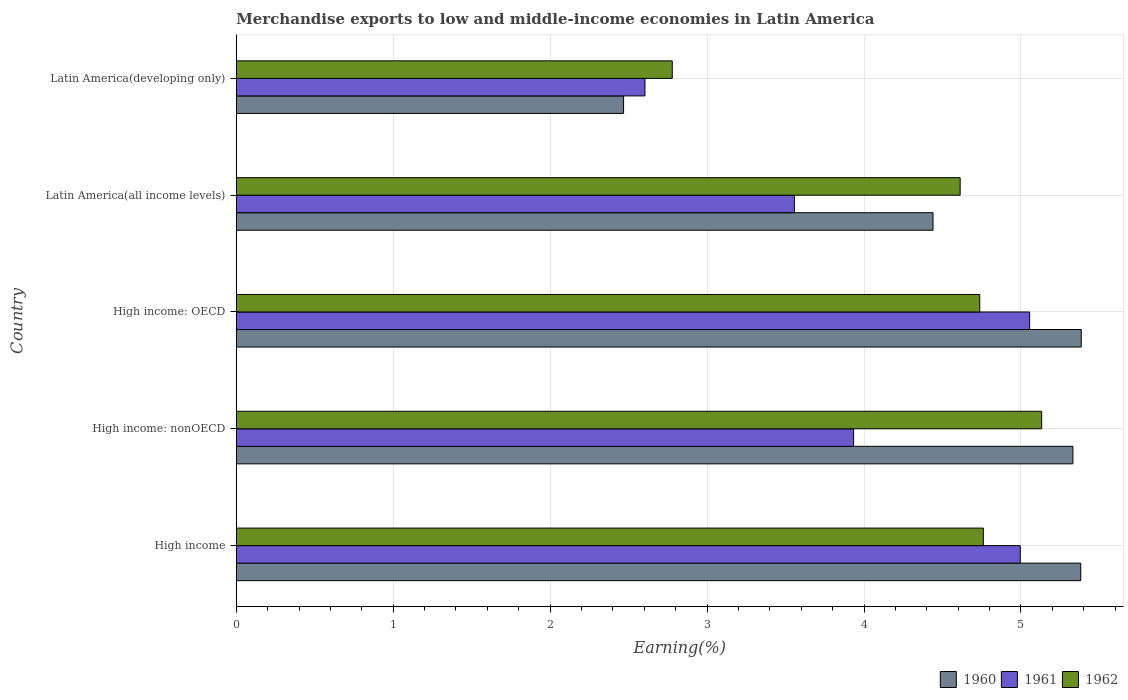How many different coloured bars are there?
Your answer should be compact. 3. Are the number of bars per tick equal to the number of legend labels?
Keep it short and to the point. Yes. Are the number of bars on each tick of the Y-axis equal?
Provide a short and direct response. Yes. What is the label of the 5th group of bars from the top?
Your response must be concise. High income. What is the percentage of amount earned from merchandise exports in 1962 in High income?
Your response must be concise. 4.76. Across all countries, what is the maximum percentage of amount earned from merchandise exports in 1962?
Keep it short and to the point. 5.13. Across all countries, what is the minimum percentage of amount earned from merchandise exports in 1962?
Provide a succinct answer. 2.78. In which country was the percentage of amount earned from merchandise exports in 1960 maximum?
Your answer should be very brief. High income: OECD. In which country was the percentage of amount earned from merchandise exports in 1961 minimum?
Provide a short and direct response. Latin America(developing only). What is the total percentage of amount earned from merchandise exports in 1960 in the graph?
Your response must be concise. 23. What is the difference between the percentage of amount earned from merchandise exports in 1962 in High income and that in Latin America(all income levels)?
Offer a terse response. 0.15. What is the difference between the percentage of amount earned from merchandise exports in 1961 in Latin America(all income levels) and the percentage of amount earned from merchandise exports in 1960 in Latin America(developing only)?
Make the answer very short. 1.09. What is the average percentage of amount earned from merchandise exports in 1962 per country?
Ensure brevity in your answer.  4.4. What is the difference between the percentage of amount earned from merchandise exports in 1962 and percentage of amount earned from merchandise exports in 1960 in Latin America(all income levels)?
Your answer should be very brief. 0.17. In how many countries, is the percentage of amount earned from merchandise exports in 1960 greater than 2.4 %?
Your answer should be compact. 5. What is the ratio of the percentage of amount earned from merchandise exports in 1961 in High income to that in Latin America(developing only)?
Keep it short and to the point. 1.92. Is the difference between the percentage of amount earned from merchandise exports in 1962 in High income and High income: OECD greater than the difference between the percentage of amount earned from merchandise exports in 1960 in High income and High income: OECD?
Provide a succinct answer. Yes. What is the difference between the highest and the second highest percentage of amount earned from merchandise exports in 1960?
Keep it short and to the point. 0. What is the difference between the highest and the lowest percentage of amount earned from merchandise exports in 1961?
Offer a terse response. 2.45. In how many countries, is the percentage of amount earned from merchandise exports in 1961 greater than the average percentage of amount earned from merchandise exports in 1961 taken over all countries?
Your answer should be very brief. 2. Is the sum of the percentage of amount earned from merchandise exports in 1961 in Latin America(all income levels) and Latin America(developing only) greater than the maximum percentage of amount earned from merchandise exports in 1962 across all countries?
Provide a succinct answer. Yes. What does the 2nd bar from the top in High income: OECD represents?
Make the answer very short. 1961. Are all the bars in the graph horizontal?
Your answer should be very brief. Yes. Are the values on the major ticks of X-axis written in scientific E-notation?
Give a very brief answer. No. Does the graph contain any zero values?
Offer a terse response. No. Does the graph contain grids?
Your response must be concise. Yes. Where does the legend appear in the graph?
Provide a succinct answer. Bottom right. How are the legend labels stacked?
Your response must be concise. Horizontal. What is the title of the graph?
Your answer should be very brief. Merchandise exports to low and middle-income economies in Latin America. Does "2007" appear as one of the legend labels in the graph?
Offer a very short reply. No. What is the label or title of the X-axis?
Keep it short and to the point. Earning(%). What is the Earning(%) of 1960 in High income?
Provide a short and direct response. 5.38. What is the Earning(%) in 1961 in High income?
Your answer should be compact. 5. What is the Earning(%) in 1962 in High income?
Provide a short and direct response. 4.76. What is the Earning(%) in 1960 in High income: nonOECD?
Provide a short and direct response. 5.33. What is the Earning(%) in 1961 in High income: nonOECD?
Ensure brevity in your answer.  3.93. What is the Earning(%) in 1962 in High income: nonOECD?
Your response must be concise. 5.13. What is the Earning(%) in 1960 in High income: OECD?
Provide a short and direct response. 5.38. What is the Earning(%) of 1961 in High income: OECD?
Provide a succinct answer. 5.06. What is the Earning(%) in 1962 in High income: OECD?
Your answer should be very brief. 4.74. What is the Earning(%) in 1960 in Latin America(all income levels)?
Ensure brevity in your answer.  4.44. What is the Earning(%) in 1961 in Latin America(all income levels)?
Provide a short and direct response. 3.56. What is the Earning(%) of 1962 in Latin America(all income levels)?
Your answer should be very brief. 4.61. What is the Earning(%) in 1960 in Latin America(developing only)?
Provide a succinct answer. 2.47. What is the Earning(%) in 1961 in Latin America(developing only)?
Give a very brief answer. 2.6. What is the Earning(%) in 1962 in Latin America(developing only)?
Ensure brevity in your answer.  2.78. Across all countries, what is the maximum Earning(%) of 1960?
Your answer should be compact. 5.38. Across all countries, what is the maximum Earning(%) in 1961?
Provide a succinct answer. 5.06. Across all countries, what is the maximum Earning(%) of 1962?
Offer a very short reply. 5.13. Across all countries, what is the minimum Earning(%) in 1960?
Give a very brief answer. 2.47. Across all countries, what is the minimum Earning(%) of 1961?
Offer a terse response. 2.6. Across all countries, what is the minimum Earning(%) of 1962?
Provide a short and direct response. 2.78. What is the total Earning(%) in 1960 in the graph?
Offer a very short reply. 23. What is the total Earning(%) in 1961 in the graph?
Offer a very short reply. 20.15. What is the total Earning(%) of 1962 in the graph?
Ensure brevity in your answer.  22.02. What is the difference between the Earning(%) in 1960 in High income and that in High income: nonOECD?
Your response must be concise. 0.05. What is the difference between the Earning(%) of 1961 in High income and that in High income: nonOECD?
Keep it short and to the point. 1.06. What is the difference between the Earning(%) in 1962 in High income and that in High income: nonOECD?
Your answer should be compact. -0.37. What is the difference between the Earning(%) of 1960 in High income and that in High income: OECD?
Offer a very short reply. -0. What is the difference between the Earning(%) in 1961 in High income and that in High income: OECD?
Your answer should be very brief. -0.06. What is the difference between the Earning(%) of 1962 in High income and that in High income: OECD?
Your answer should be compact. 0.02. What is the difference between the Earning(%) of 1960 in High income and that in Latin America(all income levels)?
Make the answer very short. 0.94. What is the difference between the Earning(%) in 1961 in High income and that in Latin America(all income levels)?
Make the answer very short. 1.44. What is the difference between the Earning(%) in 1962 in High income and that in Latin America(all income levels)?
Ensure brevity in your answer.  0.15. What is the difference between the Earning(%) of 1960 in High income and that in Latin America(developing only)?
Offer a terse response. 2.91. What is the difference between the Earning(%) of 1961 in High income and that in Latin America(developing only)?
Keep it short and to the point. 2.39. What is the difference between the Earning(%) of 1962 in High income and that in Latin America(developing only)?
Your answer should be very brief. 1.98. What is the difference between the Earning(%) in 1960 in High income: nonOECD and that in High income: OECD?
Your answer should be very brief. -0.05. What is the difference between the Earning(%) of 1961 in High income: nonOECD and that in High income: OECD?
Provide a succinct answer. -1.12. What is the difference between the Earning(%) in 1962 in High income: nonOECD and that in High income: OECD?
Give a very brief answer. 0.39. What is the difference between the Earning(%) of 1960 in High income: nonOECD and that in Latin America(all income levels)?
Give a very brief answer. 0.89. What is the difference between the Earning(%) in 1961 in High income: nonOECD and that in Latin America(all income levels)?
Give a very brief answer. 0.38. What is the difference between the Earning(%) in 1962 in High income: nonOECD and that in Latin America(all income levels)?
Ensure brevity in your answer.  0.52. What is the difference between the Earning(%) in 1960 in High income: nonOECD and that in Latin America(developing only)?
Ensure brevity in your answer.  2.86. What is the difference between the Earning(%) of 1961 in High income: nonOECD and that in Latin America(developing only)?
Your answer should be compact. 1.33. What is the difference between the Earning(%) of 1962 in High income: nonOECD and that in Latin America(developing only)?
Ensure brevity in your answer.  2.35. What is the difference between the Earning(%) in 1960 in High income: OECD and that in Latin America(all income levels)?
Your answer should be very brief. 0.94. What is the difference between the Earning(%) in 1961 in High income: OECD and that in Latin America(all income levels)?
Provide a succinct answer. 1.5. What is the difference between the Earning(%) in 1962 in High income: OECD and that in Latin America(all income levels)?
Give a very brief answer. 0.12. What is the difference between the Earning(%) in 1960 in High income: OECD and that in Latin America(developing only)?
Make the answer very short. 2.92. What is the difference between the Earning(%) in 1961 in High income: OECD and that in Latin America(developing only)?
Offer a very short reply. 2.45. What is the difference between the Earning(%) in 1962 in High income: OECD and that in Latin America(developing only)?
Your response must be concise. 1.96. What is the difference between the Earning(%) in 1960 in Latin America(all income levels) and that in Latin America(developing only)?
Provide a short and direct response. 1.97. What is the difference between the Earning(%) in 1961 in Latin America(all income levels) and that in Latin America(developing only)?
Offer a terse response. 0.95. What is the difference between the Earning(%) in 1962 in Latin America(all income levels) and that in Latin America(developing only)?
Provide a short and direct response. 1.83. What is the difference between the Earning(%) in 1960 in High income and the Earning(%) in 1961 in High income: nonOECD?
Provide a short and direct response. 1.45. What is the difference between the Earning(%) of 1960 in High income and the Earning(%) of 1962 in High income: nonOECD?
Offer a very short reply. 0.25. What is the difference between the Earning(%) in 1961 in High income and the Earning(%) in 1962 in High income: nonOECD?
Offer a terse response. -0.14. What is the difference between the Earning(%) in 1960 in High income and the Earning(%) in 1961 in High income: OECD?
Offer a terse response. 0.33. What is the difference between the Earning(%) of 1960 in High income and the Earning(%) of 1962 in High income: OECD?
Your answer should be compact. 0.64. What is the difference between the Earning(%) in 1961 in High income and the Earning(%) in 1962 in High income: OECD?
Your answer should be very brief. 0.26. What is the difference between the Earning(%) in 1960 in High income and the Earning(%) in 1961 in Latin America(all income levels)?
Your answer should be very brief. 1.82. What is the difference between the Earning(%) of 1960 in High income and the Earning(%) of 1962 in Latin America(all income levels)?
Provide a short and direct response. 0.77. What is the difference between the Earning(%) in 1961 in High income and the Earning(%) in 1962 in Latin America(all income levels)?
Keep it short and to the point. 0.38. What is the difference between the Earning(%) of 1960 in High income and the Earning(%) of 1961 in Latin America(developing only)?
Ensure brevity in your answer.  2.78. What is the difference between the Earning(%) of 1960 in High income and the Earning(%) of 1962 in Latin America(developing only)?
Give a very brief answer. 2.6. What is the difference between the Earning(%) in 1961 in High income and the Earning(%) in 1962 in Latin America(developing only)?
Ensure brevity in your answer.  2.22. What is the difference between the Earning(%) in 1960 in High income: nonOECD and the Earning(%) in 1961 in High income: OECD?
Provide a succinct answer. 0.28. What is the difference between the Earning(%) in 1960 in High income: nonOECD and the Earning(%) in 1962 in High income: OECD?
Your answer should be compact. 0.59. What is the difference between the Earning(%) in 1961 in High income: nonOECD and the Earning(%) in 1962 in High income: OECD?
Your answer should be compact. -0.8. What is the difference between the Earning(%) of 1960 in High income: nonOECD and the Earning(%) of 1961 in Latin America(all income levels)?
Offer a terse response. 1.77. What is the difference between the Earning(%) in 1960 in High income: nonOECD and the Earning(%) in 1962 in Latin America(all income levels)?
Your response must be concise. 0.72. What is the difference between the Earning(%) of 1961 in High income: nonOECD and the Earning(%) of 1962 in Latin America(all income levels)?
Your response must be concise. -0.68. What is the difference between the Earning(%) in 1960 in High income: nonOECD and the Earning(%) in 1961 in Latin America(developing only)?
Make the answer very short. 2.73. What is the difference between the Earning(%) of 1960 in High income: nonOECD and the Earning(%) of 1962 in Latin America(developing only)?
Offer a very short reply. 2.55. What is the difference between the Earning(%) of 1961 in High income: nonOECD and the Earning(%) of 1962 in Latin America(developing only)?
Provide a short and direct response. 1.16. What is the difference between the Earning(%) of 1960 in High income: OECD and the Earning(%) of 1961 in Latin America(all income levels)?
Keep it short and to the point. 1.83. What is the difference between the Earning(%) of 1960 in High income: OECD and the Earning(%) of 1962 in Latin America(all income levels)?
Make the answer very short. 0.77. What is the difference between the Earning(%) of 1961 in High income: OECD and the Earning(%) of 1962 in Latin America(all income levels)?
Your answer should be very brief. 0.44. What is the difference between the Earning(%) of 1960 in High income: OECD and the Earning(%) of 1961 in Latin America(developing only)?
Ensure brevity in your answer.  2.78. What is the difference between the Earning(%) in 1960 in High income: OECD and the Earning(%) in 1962 in Latin America(developing only)?
Keep it short and to the point. 2.61. What is the difference between the Earning(%) of 1961 in High income: OECD and the Earning(%) of 1962 in Latin America(developing only)?
Your answer should be compact. 2.28. What is the difference between the Earning(%) of 1960 in Latin America(all income levels) and the Earning(%) of 1961 in Latin America(developing only)?
Keep it short and to the point. 1.84. What is the difference between the Earning(%) in 1960 in Latin America(all income levels) and the Earning(%) in 1962 in Latin America(developing only)?
Make the answer very short. 1.66. What is the difference between the Earning(%) in 1961 in Latin America(all income levels) and the Earning(%) in 1962 in Latin America(developing only)?
Make the answer very short. 0.78. What is the average Earning(%) in 1960 per country?
Your answer should be compact. 4.6. What is the average Earning(%) of 1961 per country?
Make the answer very short. 4.03. What is the average Earning(%) in 1962 per country?
Ensure brevity in your answer.  4.4. What is the difference between the Earning(%) in 1960 and Earning(%) in 1961 in High income?
Your answer should be compact. 0.39. What is the difference between the Earning(%) of 1960 and Earning(%) of 1962 in High income?
Make the answer very short. 0.62. What is the difference between the Earning(%) of 1961 and Earning(%) of 1962 in High income?
Provide a short and direct response. 0.24. What is the difference between the Earning(%) of 1960 and Earning(%) of 1961 in High income: nonOECD?
Keep it short and to the point. 1.4. What is the difference between the Earning(%) of 1960 and Earning(%) of 1962 in High income: nonOECD?
Your answer should be very brief. 0.2. What is the difference between the Earning(%) of 1961 and Earning(%) of 1962 in High income: nonOECD?
Your answer should be compact. -1.2. What is the difference between the Earning(%) in 1960 and Earning(%) in 1961 in High income: OECD?
Provide a succinct answer. 0.33. What is the difference between the Earning(%) of 1960 and Earning(%) of 1962 in High income: OECD?
Give a very brief answer. 0.65. What is the difference between the Earning(%) of 1961 and Earning(%) of 1962 in High income: OECD?
Offer a terse response. 0.32. What is the difference between the Earning(%) of 1960 and Earning(%) of 1961 in Latin America(all income levels)?
Ensure brevity in your answer.  0.88. What is the difference between the Earning(%) in 1960 and Earning(%) in 1962 in Latin America(all income levels)?
Your answer should be very brief. -0.17. What is the difference between the Earning(%) of 1961 and Earning(%) of 1962 in Latin America(all income levels)?
Offer a terse response. -1.06. What is the difference between the Earning(%) of 1960 and Earning(%) of 1961 in Latin America(developing only)?
Offer a terse response. -0.14. What is the difference between the Earning(%) in 1960 and Earning(%) in 1962 in Latin America(developing only)?
Offer a very short reply. -0.31. What is the difference between the Earning(%) of 1961 and Earning(%) of 1962 in Latin America(developing only)?
Make the answer very short. -0.17. What is the ratio of the Earning(%) in 1960 in High income to that in High income: nonOECD?
Your answer should be very brief. 1.01. What is the ratio of the Earning(%) of 1961 in High income to that in High income: nonOECD?
Your response must be concise. 1.27. What is the ratio of the Earning(%) of 1962 in High income to that in High income: nonOECD?
Offer a terse response. 0.93. What is the ratio of the Earning(%) of 1960 in High income to that in High income: OECD?
Provide a succinct answer. 1. What is the ratio of the Earning(%) in 1960 in High income to that in Latin America(all income levels)?
Make the answer very short. 1.21. What is the ratio of the Earning(%) in 1961 in High income to that in Latin America(all income levels)?
Make the answer very short. 1.4. What is the ratio of the Earning(%) in 1962 in High income to that in Latin America(all income levels)?
Ensure brevity in your answer.  1.03. What is the ratio of the Earning(%) of 1960 in High income to that in Latin America(developing only)?
Your answer should be compact. 2.18. What is the ratio of the Earning(%) in 1961 in High income to that in Latin America(developing only)?
Your answer should be compact. 1.92. What is the ratio of the Earning(%) in 1962 in High income to that in Latin America(developing only)?
Your response must be concise. 1.71. What is the ratio of the Earning(%) of 1960 in High income: nonOECD to that in High income: OECD?
Your response must be concise. 0.99. What is the ratio of the Earning(%) of 1961 in High income: nonOECD to that in High income: OECD?
Provide a short and direct response. 0.78. What is the ratio of the Earning(%) of 1962 in High income: nonOECD to that in High income: OECD?
Make the answer very short. 1.08. What is the ratio of the Earning(%) in 1960 in High income: nonOECD to that in Latin America(all income levels)?
Make the answer very short. 1.2. What is the ratio of the Earning(%) of 1961 in High income: nonOECD to that in Latin America(all income levels)?
Your response must be concise. 1.11. What is the ratio of the Earning(%) in 1962 in High income: nonOECD to that in Latin America(all income levels)?
Your answer should be very brief. 1.11. What is the ratio of the Earning(%) in 1960 in High income: nonOECD to that in Latin America(developing only)?
Give a very brief answer. 2.16. What is the ratio of the Earning(%) in 1961 in High income: nonOECD to that in Latin America(developing only)?
Offer a terse response. 1.51. What is the ratio of the Earning(%) in 1962 in High income: nonOECD to that in Latin America(developing only)?
Make the answer very short. 1.85. What is the ratio of the Earning(%) in 1960 in High income: OECD to that in Latin America(all income levels)?
Your response must be concise. 1.21. What is the ratio of the Earning(%) of 1961 in High income: OECD to that in Latin America(all income levels)?
Your answer should be very brief. 1.42. What is the ratio of the Earning(%) of 1960 in High income: OECD to that in Latin America(developing only)?
Offer a terse response. 2.18. What is the ratio of the Earning(%) of 1961 in High income: OECD to that in Latin America(developing only)?
Ensure brevity in your answer.  1.94. What is the ratio of the Earning(%) of 1962 in High income: OECD to that in Latin America(developing only)?
Your response must be concise. 1.71. What is the ratio of the Earning(%) of 1960 in Latin America(all income levels) to that in Latin America(developing only)?
Ensure brevity in your answer.  1.8. What is the ratio of the Earning(%) in 1961 in Latin America(all income levels) to that in Latin America(developing only)?
Keep it short and to the point. 1.37. What is the ratio of the Earning(%) in 1962 in Latin America(all income levels) to that in Latin America(developing only)?
Make the answer very short. 1.66. What is the difference between the highest and the second highest Earning(%) of 1960?
Give a very brief answer. 0. What is the difference between the highest and the second highest Earning(%) of 1962?
Your answer should be very brief. 0.37. What is the difference between the highest and the lowest Earning(%) of 1960?
Your response must be concise. 2.92. What is the difference between the highest and the lowest Earning(%) in 1961?
Keep it short and to the point. 2.45. What is the difference between the highest and the lowest Earning(%) of 1962?
Provide a short and direct response. 2.35. 